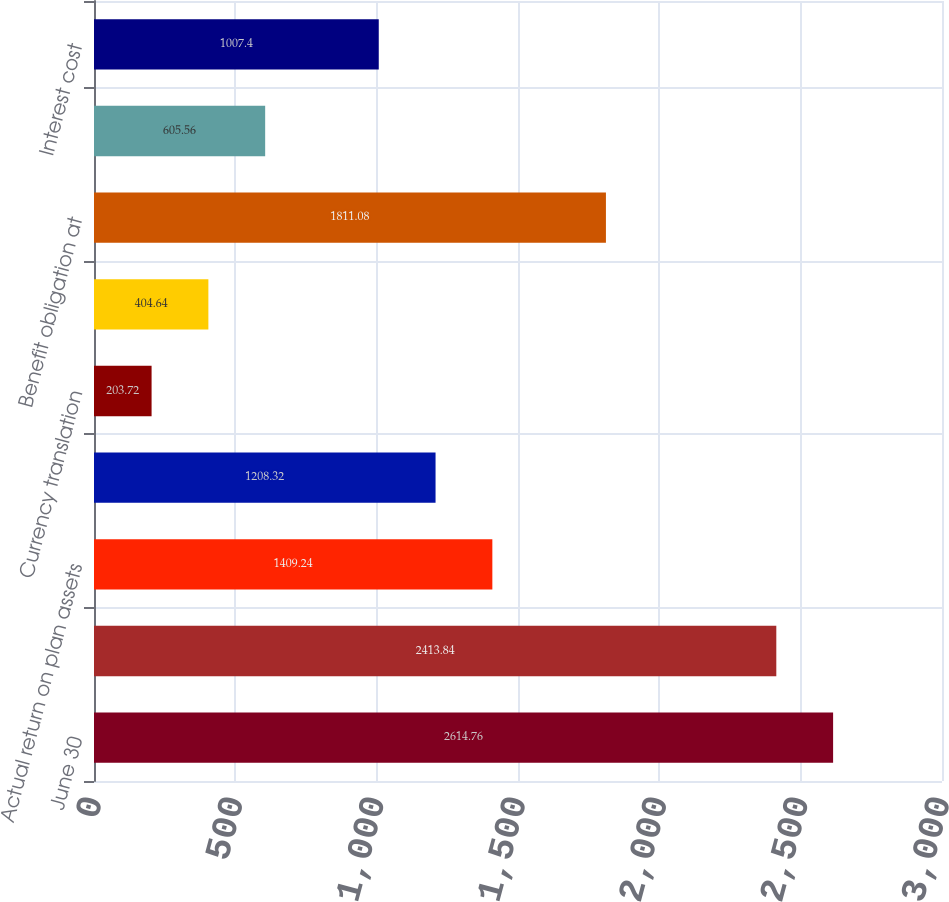Convert chart to OTSL. <chart><loc_0><loc_0><loc_500><loc_500><bar_chart><fcel>June 30<fcel>Fair value of plan assets at<fcel>Actual return on plan assets<fcel>Employer contributions<fcel>Currency translation<fcel>Benefits paid<fcel>Benefit obligation at<fcel>Service cost<fcel>Interest cost<nl><fcel>2614.76<fcel>2413.84<fcel>1409.24<fcel>1208.32<fcel>203.72<fcel>404.64<fcel>1811.08<fcel>605.56<fcel>1007.4<nl></chart> 